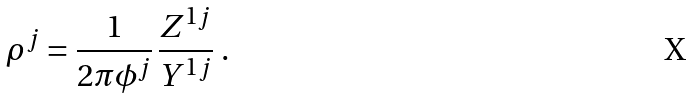Convert formula to latex. <formula><loc_0><loc_0><loc_500><loc_500>\rho ^ { j } = \frac { 1 } { 2 \pi \phi ^ { j } } \, \frac { Z ^ { 1 j } } { Y ^ { 1 j } } \ .</formula> 